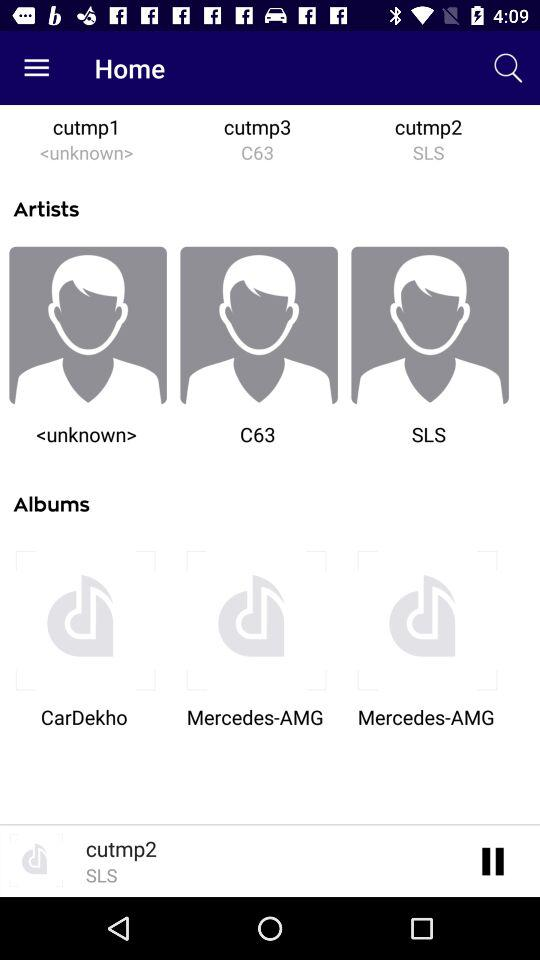What is the name of the album that is playing? The name of the album is cutmp2. 